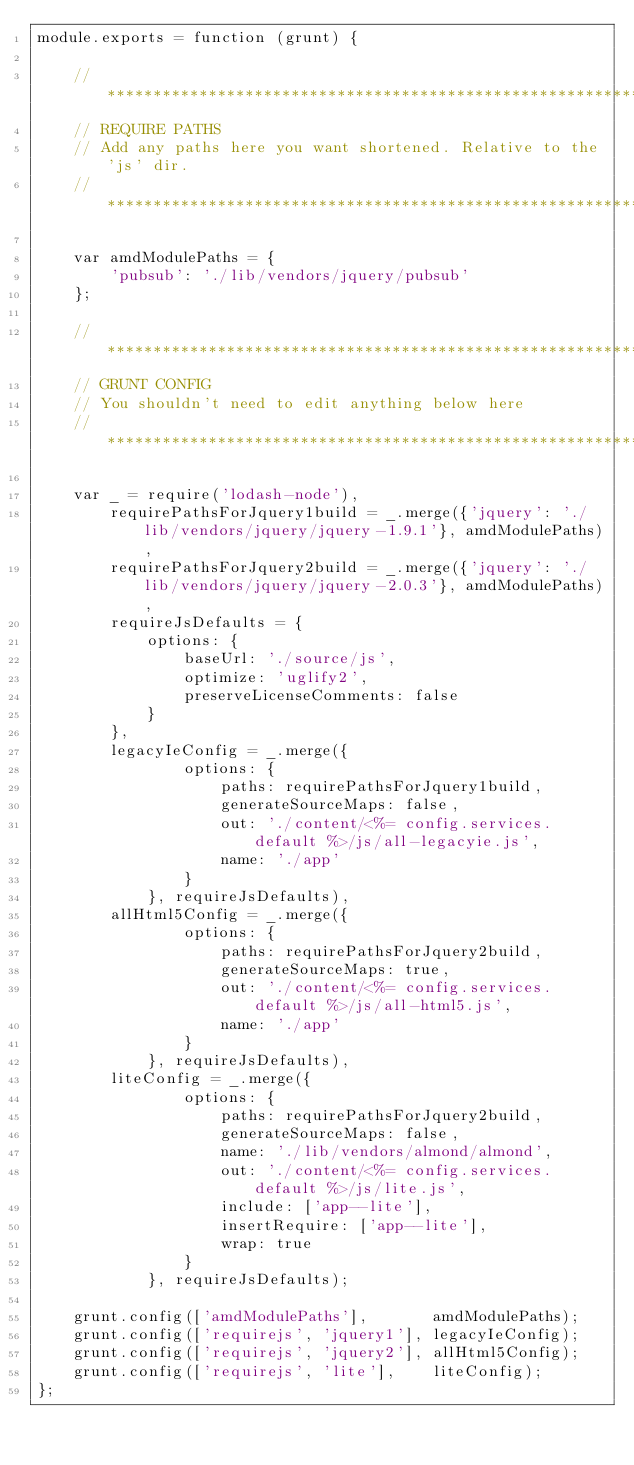<code> <loc_0><loc_0><loc_500><loc_500><_JavaScript_>module.exports = function (grunt) {

    // *************************************************************************
    // REQUIRE PATHS
    // Add any paths here you want shortened. Relative to the 'js' dir.
    // *************************************************************************

    var amdModulePaths = {
        'pubsub': './lib/vendors/jquery/pubsub'
    };

    // *************************************************************************
    // GRUNT CONFIG
    // You shouldn't need to edit anything below here
    // *************************************************************************

    var _ = require('lodash-node'),
        requirePathsForJquery1build = _.merge({'jquery': './lib/vendors/jquery/jquery-1.9.1'}, amdModulePaths),
        requirePathsForJquery2build = _.merge({'jquery': './lib/vendors/jquery/jquery-2.0.3'}, amdModulePaths),
        requireJsDefaults = {
            options: {
                baseUrl: './source/js',
                optimize: 'uglify2',
                preserveLicenseComments: false
            }
        },
        legacyIeConfig = _.merge({
                options: {
                    paths: requirePathsForJquery1build,
                    generateSourceMaps: false,
                    out: './content/<%= config.services.default %>/js/all-legacyie.js',
                    name: './app'
                }
            }, requireJsDefaults),
        allHtml5Config = _.merge({
                options: {
                    paths: requirePathsForJquery2build,
                    generateSourceMaps: true,
                    out: './content/<%= config.services.default %>/js/all-html5.js',
                    name: './app'
                }
            }, requireJsDefaults),
        liteConfig = _.merge({
                options: {
                    paths: requirePathsForJquery2build,
                    generateSourceMaps: false,
                    name: './lib/vendors/almond/almond',
                    out: './content/<%= config.services.default %>/js/lite.js',
                    include: ['app--lite'],
                    insertRequire: ['app--lite'],
                    wrap: true
                }
            }, requireJsDefaults);

    grunt.config(['amdModulePaths'],       amdModulePaths);
    grunt.config(['requirejs', 'jquery1'], legacyIeConfig);
    grunt.config(['requirejs', 'jquery2'], allHtml5Config);
    grunt.config(['requirejs', 'lite'],    liteConfig);
};</code> 